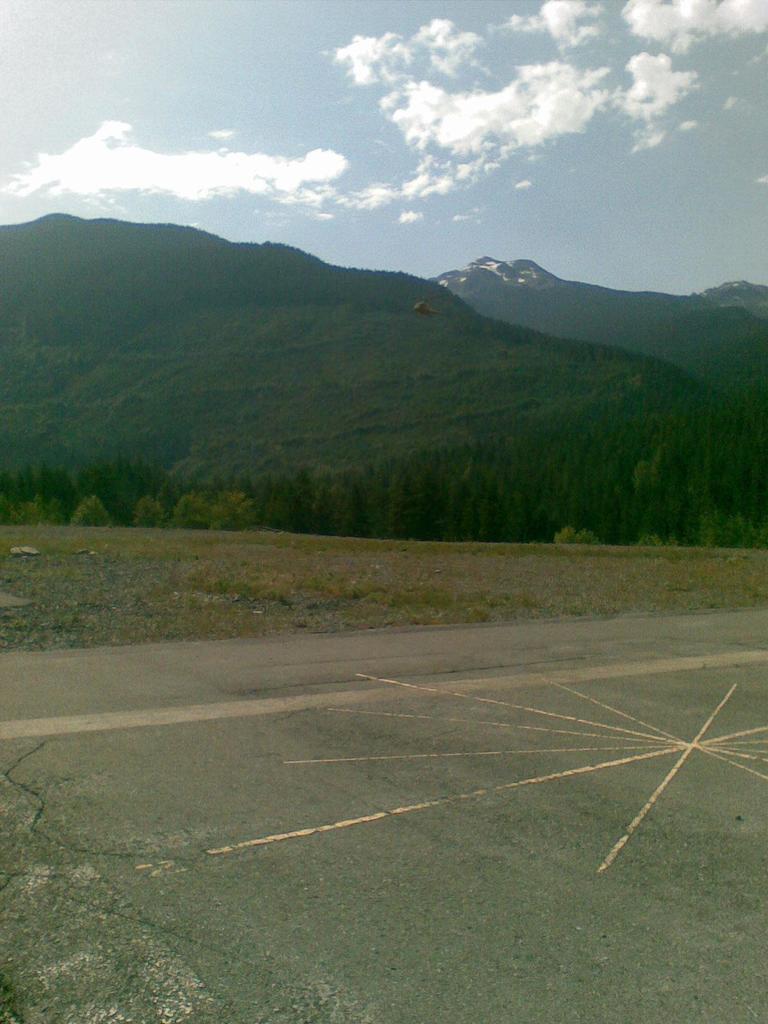Please provide a concise description of this image. In this picture I can see a helicopter flying. There are trees, hills, and in the background there is the sky. 